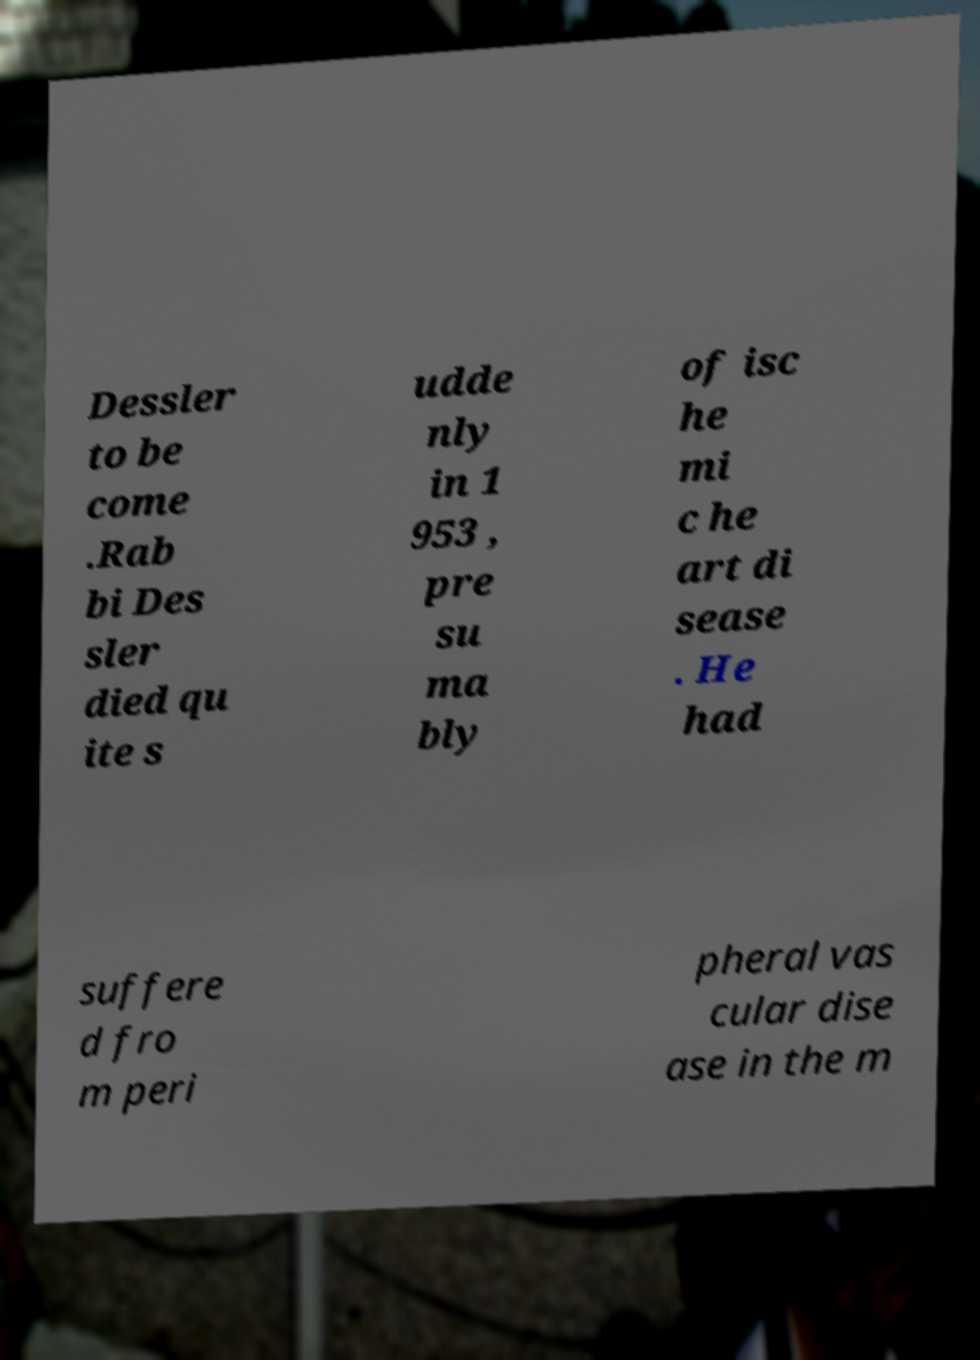Could you assist in decoding the text presented in this image and type it out clearly? Dessler to be come .Rab bi Des sler died qu ite s udde nly in 1 953 , pre su ma bly of isc he mi c he art di sease . He had suffere d fro m peri pheral vas cular dise ase in the m 